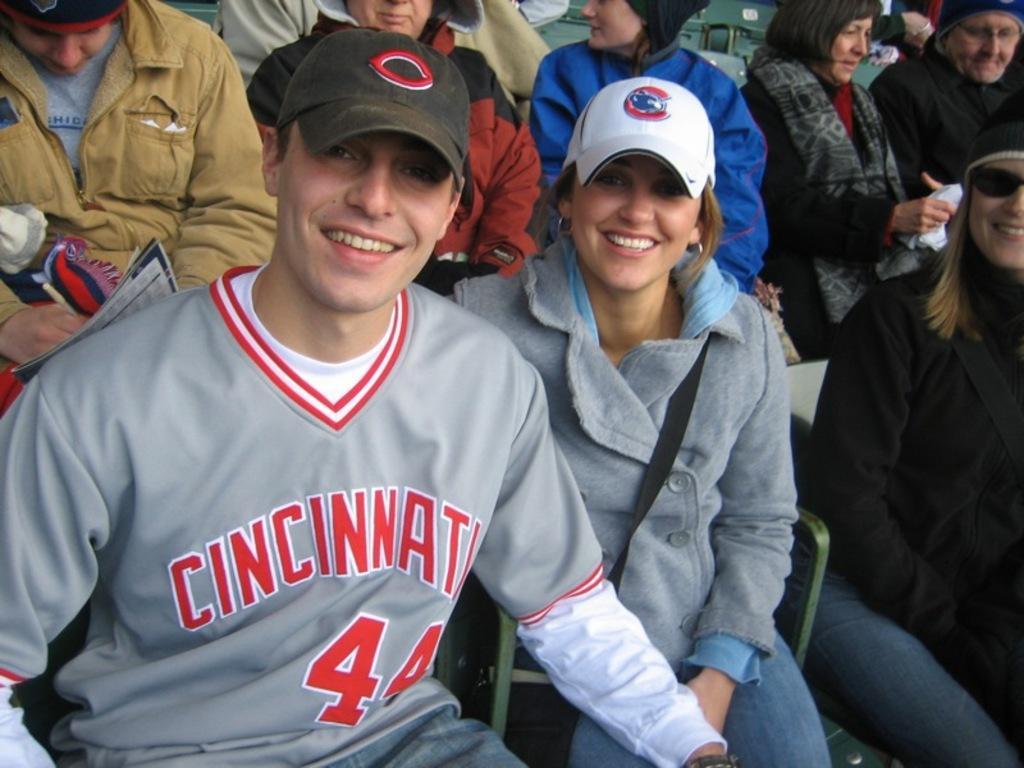Could you give a brief overview of what you see in this image? There is one man and a woman is sitting on the chairs at the bottom of this image, The woman is wearing a white color cap. There are some other persons sitting in the background. 